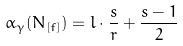Convert formula to latex. <formula><loc_0><loc_0><loc_500><loc_500>\alpha _ { \gamma } ( N _ { [ f ] } ) = l \cdot \frac { s } { r } + \frac { s - 1 } { 2 }</formula> 